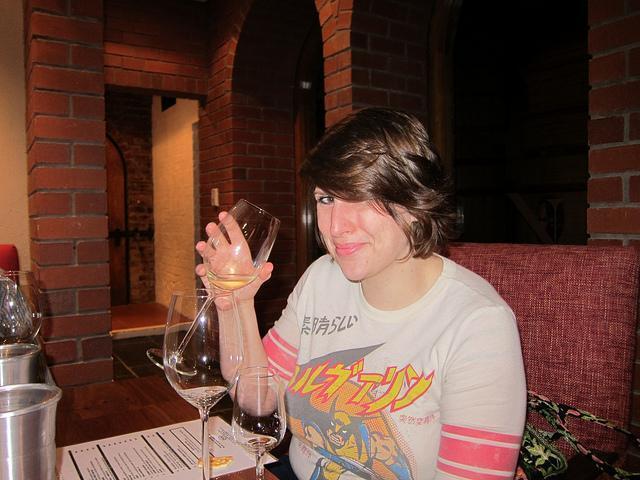How many couches are there?
Give a very brief answer. 1. How many wine glasses are in the photo?
Give a very brief answer. 4. How many banana stems without bananas are there?
Give a very brief answer. 0. 